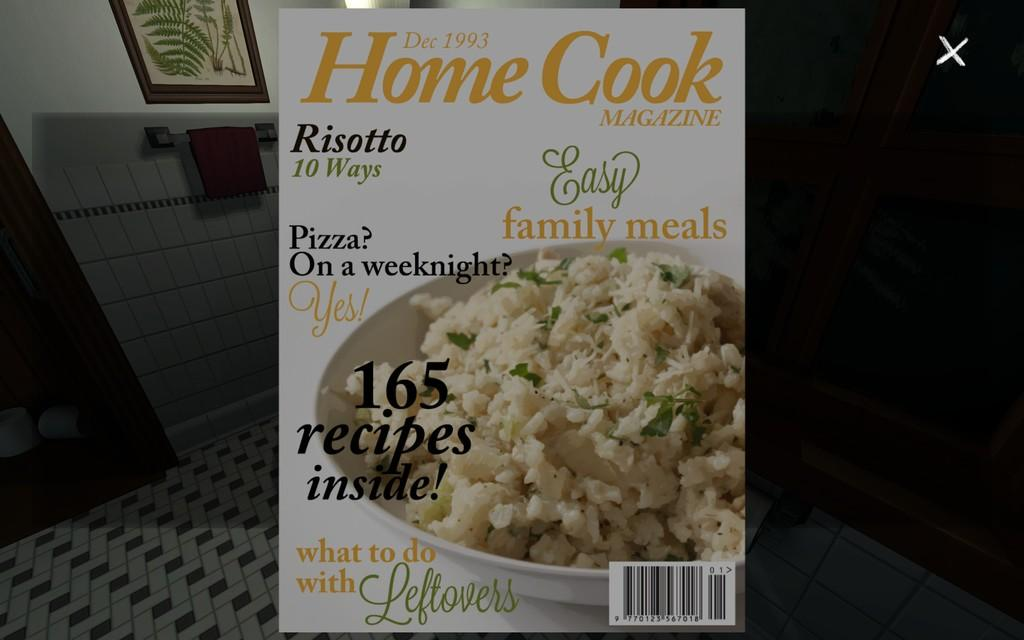What is the main subject of the image? The main subject of the image is the cover page of a magazine. What can be seen in the background of the image? There is a wall and a photo frame in the background of the image. What type of sock is hanging from the photo frame in the image? There is no sock present in the image; it only features a cover page of a magazine, a wall, and a photo frame. 